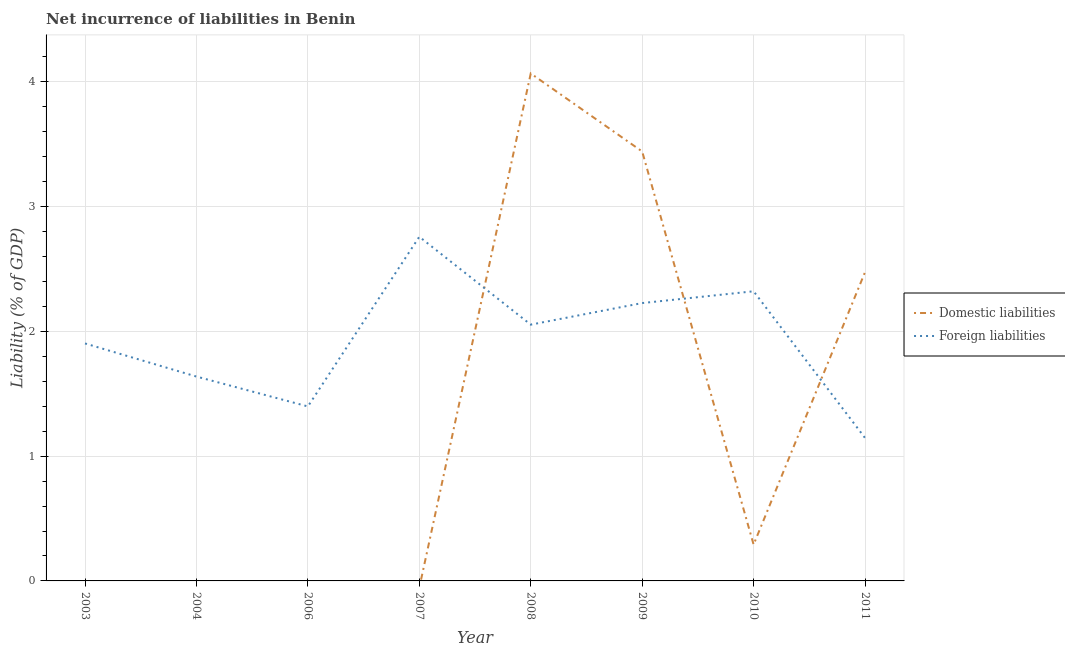How many different coloured lines are there?
Keep it short and to the point. 2. Is the number of lines equal to the number of legend labels?
Your response must be concise. No. What is the incurrence of foreign liabilities in 2003?
Provide a short and direct response. 1.9. Across all years, what is the maximum incurrence of domestic liabilities?
Your response must be concise. 4.07. Across all years, what is the minimum incurrence of domestic liabilities?
Offer a terse response. 0. What is the total incurrence of foreign liabilities in the graph?
Provide a short and direct response. 15.45. What is the difference between the incurrence of foreign liabilities in 2003 and that in 2006?
Give a very brief answer. 0.5. What is the difference between the incurrence of foreign liabilities in 2004 and the incurrence of domestic liabilities in 2008?
Your answer should be very brief. -2.43. What is the average incurrence of foreign liabilities per year?
Your answer should be very brief. 1.93. In the year 2011, what is the difference between the incurrence of domestic liabilities and incurrence of foreign liabilities?
Your answer should be very brief. 1.33. In how many years, is the incurrence of foreign liabilities greater than 1.6 %?
Keep it short and to the point. 6. What is the ratio of the incurrence of foreign liabilities in 2007 to that in 2008?
Offer a terse response. 1.34. What is the difference between the highest and the second highest incurrence of foreign liabilities?
Provide a succinct answer. 0.44. What is the difference between the highest and the lowest incurrence of foreign liabilities?
Your answer should be very brief. 1.61. In how many years, is the incurrence of foreign liabilities greater than the average incurrence of foreign liabilities taken over all years?
Your answer should be compact. 4. Is the sum of the incurrence of domestic liabilities in 2009 and 2011 greater than the maximum incurrence of foreign liabilities across all years?
Provide a short and direct response. Yes. Is the incurrence of foreign liabilities strictly less than the incurrence of domestic liabilities over the years?
Make the answer very short. No. How many lines are there?
Give a very brief answer. 2. Are the values on the major ticks of Y-axis written in scientific E-notation?
Provide a succinct answer. No. Where does the legend appear in the graph?
Your answer should be very brief. Center right. What is the title of the graph?
Provide a succinct answer. Net incurrence of liabilities in Benin. Does "Age 65(male)" appear as one of the legend labels in the graph?
Provide a succinct answer. No. What is the label or title of the Y-axis?
Give a very brief answer. Liability (% of GDP). What is the Liability (% of GDP) in Foreign liabilities in 2003?
Make the answer very short. 1.9. What is the Liability (% of GDP) in Foreign liabilities in 2004?
Offer a terse response. 1.64. What is the Liability (% of GDP) in Domestic liabilities in 2006?
Make the answer very short. 0. What is the Liability (% of GDP) in Foreign liabilities in 2006?
Your response must be concise. 1.4. What is the Liability (% of GDP) in Foreign liabilities in 2007?
Offer a very short reply. 2.76. What is the Liability (% of GDP) in Domestic liabilities in 2008?
Your answer should be very brief. 4.07. What is the Liability (% of GDP) in Foreign liabilities in 2008?
Provide a short and direct response. 2.05. What is the Liability (% of GDP) in Domestic liabilities in 2009?
Ensure brevity in your answer.  3.44. What is the Liability (% of GDP) of Foreign liabilities in 2009?
Your response must be concise. 2.23. What is the Liability (% of GDP) in Domestic liabilities in 2010?
Your answer should be very brief. 0.29. What is the Liability (% of GDP) of Foreign liabilities in 2010?
Offer a very short reply. 2.32. What is the Liability (% of GDP) in Domestic liabilities in 2011?
Provide a succinct answer. 2.47. What is the Liability (% of GDP) of Foreign liabilities in 2011?
Offer a terse response. 1.15. Across all years, what is the maximum Liability (% of GDP) of Domestic liabilities?
Make the answer very short. 4.07. Across all years, what is the maximum Liability (% of GDP) in Foreign liabilities?
Your response must be concise. 2.76. Across all years, what is the minimum Liability (% of GDP) in Foreign liabilities?
Make the answer very short. 1.15. What is the total Liability (% of GDP) in Domestic liabilities in the graph?
Your response must be concise. 10.28. What is the total Liability (% of GDP) of Foreign liabilities in the graph?
Give a very brief answer. 15.45. What is the difference between the Liability (% of GDP) of Foreign liabilities in 2003 and that in 2004?
Offer a very short reply. 0.27. What is the difference between the Liability (% of GDP) in Foreign liabilities in 2003 and that in 2006?
Provide a succinct answer. 0.5. What is the difference between the Liability (% of GDP) of Foreign liabilities in 2003 and that in 2007?
Make the answer very short. -0.86. What is the difference between the Liability (% of GDP) of Foreign liabilities in 2003 and that in 2008?
Your answer should be very brief. -0.15. What is the difference between the Liability (% of GDP) of Foreign liabilities in 2003 and that in 2009?
Make the answer very short. -0.32. What is the difference between the Liability (% of GDP) in Foreign liabilities in 2003 and that in 2010?
Offer a very short reply. -0.42. What is the difference between the Liability (% of GDP) of Foreign liabilities in 2003 and that in 2011?
Your answer should be compact. 0.76. What is the difference between the Liability (% of GDP) of Foreign liabilities in 2004 and that in 2006?
Your answer should be compact. 0.24. What is the difference between the Liability (% of GDP) of Foreign liabilities in 2004 and that in 2007?
Your response must be concise. -1.12. What is the difference between the Liability (% of GDP) in Foreign liabilities in 2004 and that in 2008?
Your response must be concise. -0.42. What is the difference between the Liability (% of GDP) of Foreign liabilities in 2004 and that in 2009?
Ensure brevity in your answer.  -0.59. What is the difference between the Liability (% of GDP) of Foreign liabilities in 2004 and that in 2010?
Your answer should be compact. -0.68. What is the difference between the Liability (% of GDP) of Foreign liabilities in 2004 and that in 2011?
Your response must be concise. 0.49. What is the difference between the Liability (% of GDP) in Foreign liabilities in 2006 and that in 2007?
Keep it short and to the point. -1.36. What is the difference between the Liability (% of GDP) of Foreign liabilities in 2006 and that in 2008?
Make the answer very short. -0.66. What is the difference between the Liability (% of GDP) in Foreign liabilities in 2006 and that in 2009?
Your response must be concise. -0.83. What is the difference between the Liability (% of GDP) of Foreign liabilities in 2006 and that in 2010?
Make the answer very short. -0.92. What is the difference between the Liability (% of GDP) in Foreign liabilities in 2006 and that in 2011?
Offer a terse response. 0.25. What is the difference between the Liability (% of GDP) of Foreign liabilities in 2007 and that in 2008?
Your answer should be compact. 0.7. What is the difference between the Liability (% of GDP) in Foreign liabilities in 2007 and that in 2009?
Make the answer very short. 0.53. What is the difference between the Liability (% of GDP) in Foreign liabilities in 2007 and that in 2010?
Your response must be concise. 0.44. What is the difference between the Liability (% of GDP) of Foreign liabilities in 2007 and that in 2011?
Offer a terse response. 1.61. What is the difference between the Liability (% of GDP) in Domestic liabilities in 2008 and that in 2009?
Your response must be concise. 0.63. What is the difference between the Liability (% of GDP) of Foreign liabilities in 2008 and that in 2009?
Your answer should be compact. -0.17. What is the difference between the Liability (% of GDP) of Domestic liabilities in 2008 and that in 2010?
Keep it short and to the point. 3.78. What is the difference between the Liability (% of GDP) in Foreign liabilities in 2008 and that in 2010?
Your answer should be compact. -0.27. What is the difference between the Liability (% of GDP) of Domestic liabilities in 2008 and that in 2011?
Provide a succinct answer. 1.59. What is the difference between the Liability (% of GDP) of Foreign liabilities in 2008 and that in 2011?
Your response must be concise. 0.91. What is the difference between the Liability (% of GDP) of Domestic liabilities in 2009 and that in 2010?
Give a very brief answer. 3.15. What is the difference between the Liability (% of GDP) of Foreign liabilities in 2009 and that in 2010?
Your answer should be compact. -0.09. What is the difference between the Liability (% of GDP) in Foreign liabilities in 2009 and that in 2011?
Provide a succinct answer. 1.08. What is the difference between the Liability (% of GDP) of Domestic liabilities in 2010 and that in 2011?
Offer a very short reply. -2.18. What is the difference between the Liability (% of GDP) in Foreign liabilities in 2010 and that in 2011?
Offer a terse response. 1.18. What is the difference between the Liability (% of GDP) of Domestic liabilities in 2008 and the Liability (% of GDP) of Foreign liabilities in 2009?
Give a very brief answer. 1.84. What is the difference between the Liability (% of GDP) of Domestic liabilities in 2008 and the Liability (% of GDP) of Foreign liabilities in 2010?
Your answer should be compact. 1.75. What is the difference between the Liability (% of GDP) in Domestic liabilities in 2008 and the Liability (% of GDP) in Foreign liabilities in 2011?
Give a very brief answer. 2.92. What is the difference between the Liability (% of GDP) in Domestic liabilities in 2009 and the Liability (% of GDP) in Foreign liabilities in 2010?
Offer a very short reply. 1.12. What is the difference between the Liability (% of GDP) of Domestic liabilities in 2009 and the Liability (% of GDP) of Foreign liabilities in 2011?
Your answer should be compact. 2.3. What is the difference between the Liability (% of GDP) of Domestic liabilities in 2010 and the Liability (% of GDP) of Foreign liabilities in 2011?
Ensure brevity in your answer.  -0.85. What is the average Liability (% of GDP) of Domestic liabilities per year?
Your response must be concise. 1.28. What is the average Liability (% of GDP) of Foreign liabilities per year?
Keep it short and to the point. 1.93. In the year 2008, what is the difference between the Liability (% of GDP) in Domestic liabilities and Liability (% of GDP) in Foreign liabilities?
Your answer should be very brief. 2.01. In the year 2009, what is the difference between the Liability (% of GDP) of Domestic liabilities and Liability (% of GDP) of Foreign liabilities?
Make the answer very short. 1.22. In the year 2010, what is the difference between the Liability (% of GDP) of Domestic liabilities and Liability (% of GDP) of Foreign liabilities?
Give a very brief answer. -2.03. In the year 2011, what is the difference between the Liability (% of GDP) of Domestic liabilities and Liability (% of GDP) of Foreign liabilities?
Keep it short and to the point. 1.33. What is the ratio of the Liability (% of GDP) of Foreign liabilities in 2003 to that in 2004?
Make the answer very short. 1.16. What is the ratio of the Liability (% of GDP) in Foreign liabilities in 2003 to that in 2006?
Keep it short and to the point. 1.36. What is the ratio of the Liability (% of GDP) in Foreign liabilities in 2003 to that in 2007?
Your answer should be very brief. 0.69. What is the ratio of the Liability (% of GDP) in Foreign liabilities in 2003 to that in 2008?
Keep it short and to the point. 0.93. What is the ratio of the Liability (% of GDP) in Foreign liabilities in 2003 to that in 2009?
Ensure brevity in your answer.  0.85. What is the ratio of the Liability (% of GDP) in Foreign liabilities in 2003 to that in 2010?
Give a very brief answer. 0.82. What is the ratio of the Liability (% of GDP) in Foreign liabilities in 2003 to that in 2011?
Provide a succinct answer. 1.66. What is the ratio of the Liability (% of GDP) in Foreign liabilities in 2004 to that in 2006?
Provide a succinct answer. 1.17. What is the ratio of the Liability (% of GDP) of Foreign liabilities in 2004 to that in 2007?
Your response must be concise. 0.59. What is the ratio of the Liability (% of GDP) in Foreign liabilities in 2004 to that in 2008?
Make the answer very short. 0.8. What is the ratio of the Liability (% of GDP) of Foreign liabilities in 2004 to that in 2009?
Offer a terse response. 0.74. What is the ratio of the Liability (% of GDP) in Foreign liabilities in 2004 to that in 2010?
Give a very brief answer. 0.71. What is the ratio of the Liability (% of GDP) of Foreign liabilities in 2004 to that in 2011?
Keep it short and to the point. 1.43. What is the ratio of the Liability (% of GDP) of Foreign liabilities in 2006 to that in 2007?
Keep it short and to the point. 0.51. What is the ratio of the Liability (% of GDP) of Foreign liabilities in 2006 to that in 2008?
Provide a succinct answer. 0.68. What is the ratio of the Liability (% of GDP) in Foreign liabilities in 2006 to that in 2009?
Give a very brief answer. 0.63. What is the ratio of the Liability (% of GDP) of Foreign liabilities in 2006 to that in 2010?
Your answer should be very brief. 0.6. What is the ratio of the Liability (% of GDP) in Foreign liabilities in 2006 to that in 2011?
Offer a terse response. 1.22. What is the ratio of the Liability (% of GDP) of Foreign liabilities in 2007 to that in 2008?
Give a very brief answer. 1.34. What is the ratio of the Liability (% of GDP) of Foreign liabilities in 2007 to that in 2009?
Your answer should be very brief. 1.24. What is the ratio of the Liability (% of GDP) in Foreign liabilities in 2007 to that in 2010?
Your response must be concise. 1.19. What is the ratio of the Liability (% of GDP) of Foreign liabilities in 2007 to that in 2011?
Your answer should be compact. 2.41. What is the ratio of the Liability (% of GDP) in Domestic liabilities in 2008 to that in 2009?
Your answer should be compact. 1.18. What is the ratio of the Liability (% of GDP) in Foreign liabilities in 2008 to that in 2009?
Your response must be concise. 0.92. What is the ratio of the Liability (% of GDP) in Domestic liabilities in 2008 to that in 2010?
Your response must be concise. 13.97. What is the ratio of the Liability (% of GDP) of Foreign liabilities in 2008 to that in 2010?
Keep it short and to the point. 0.88. What is the ratio of the Liability (% of GDP) in Domestic liabilities in 2008 to that in 2011?
Provide a short and direct response. 1.64. What is the ratio of the Liability (% of GDP) in Foreign liabilities in 2008 to that in 2011?
Your response must be concise. 1.79. What is the ratio of the Liability (% of GDP) of Domestic liabilities in 2009 to that in 2010?
Make the answer very short. 11.82. What is the ratio of the Liability (% of GDP) in Foreign liabilities in 2009 to that in 2010?
Offer a terse response. 0.96. What is the ratio of the Liability (% of GDP) of Domestic liabilities in 2009 to that in 2011?
Ensure brevity in your answer.  1.39. What is the ratio of the Liability (% of GDP) in Foreign liabilities in 2009 to that in 2011?
Your answer should be compact. 1.94. What is the ratio of the Liability (% of GDP) of Domestic liabilities in 2010 to that in 2011?
Provide a succinct answer. 0.12. What is the ratio of the Liability (% of GDP) in Foreign liabilities in 2010 to that in 2011?
Ensure brevity in your answer.  2.03. What is the difference between the highest and the second highest Liability (% of GDP) of Domestic liabilities?
Offer a very short reply. 0.63. What is the difference between the highest and the second highest Liability (% of GDP) in Foreign liabilities?
Offer a terse response. 0.44. What is the difference between the highest and the lowest Liability (% of GDP) of Domestic liabilities?
Provide a succinct answer. 4.07. What is the difference between the highest and the lowest Liability (% of GDP) in Foreign liabilities?
Keep it short and to the point. 1.61. 